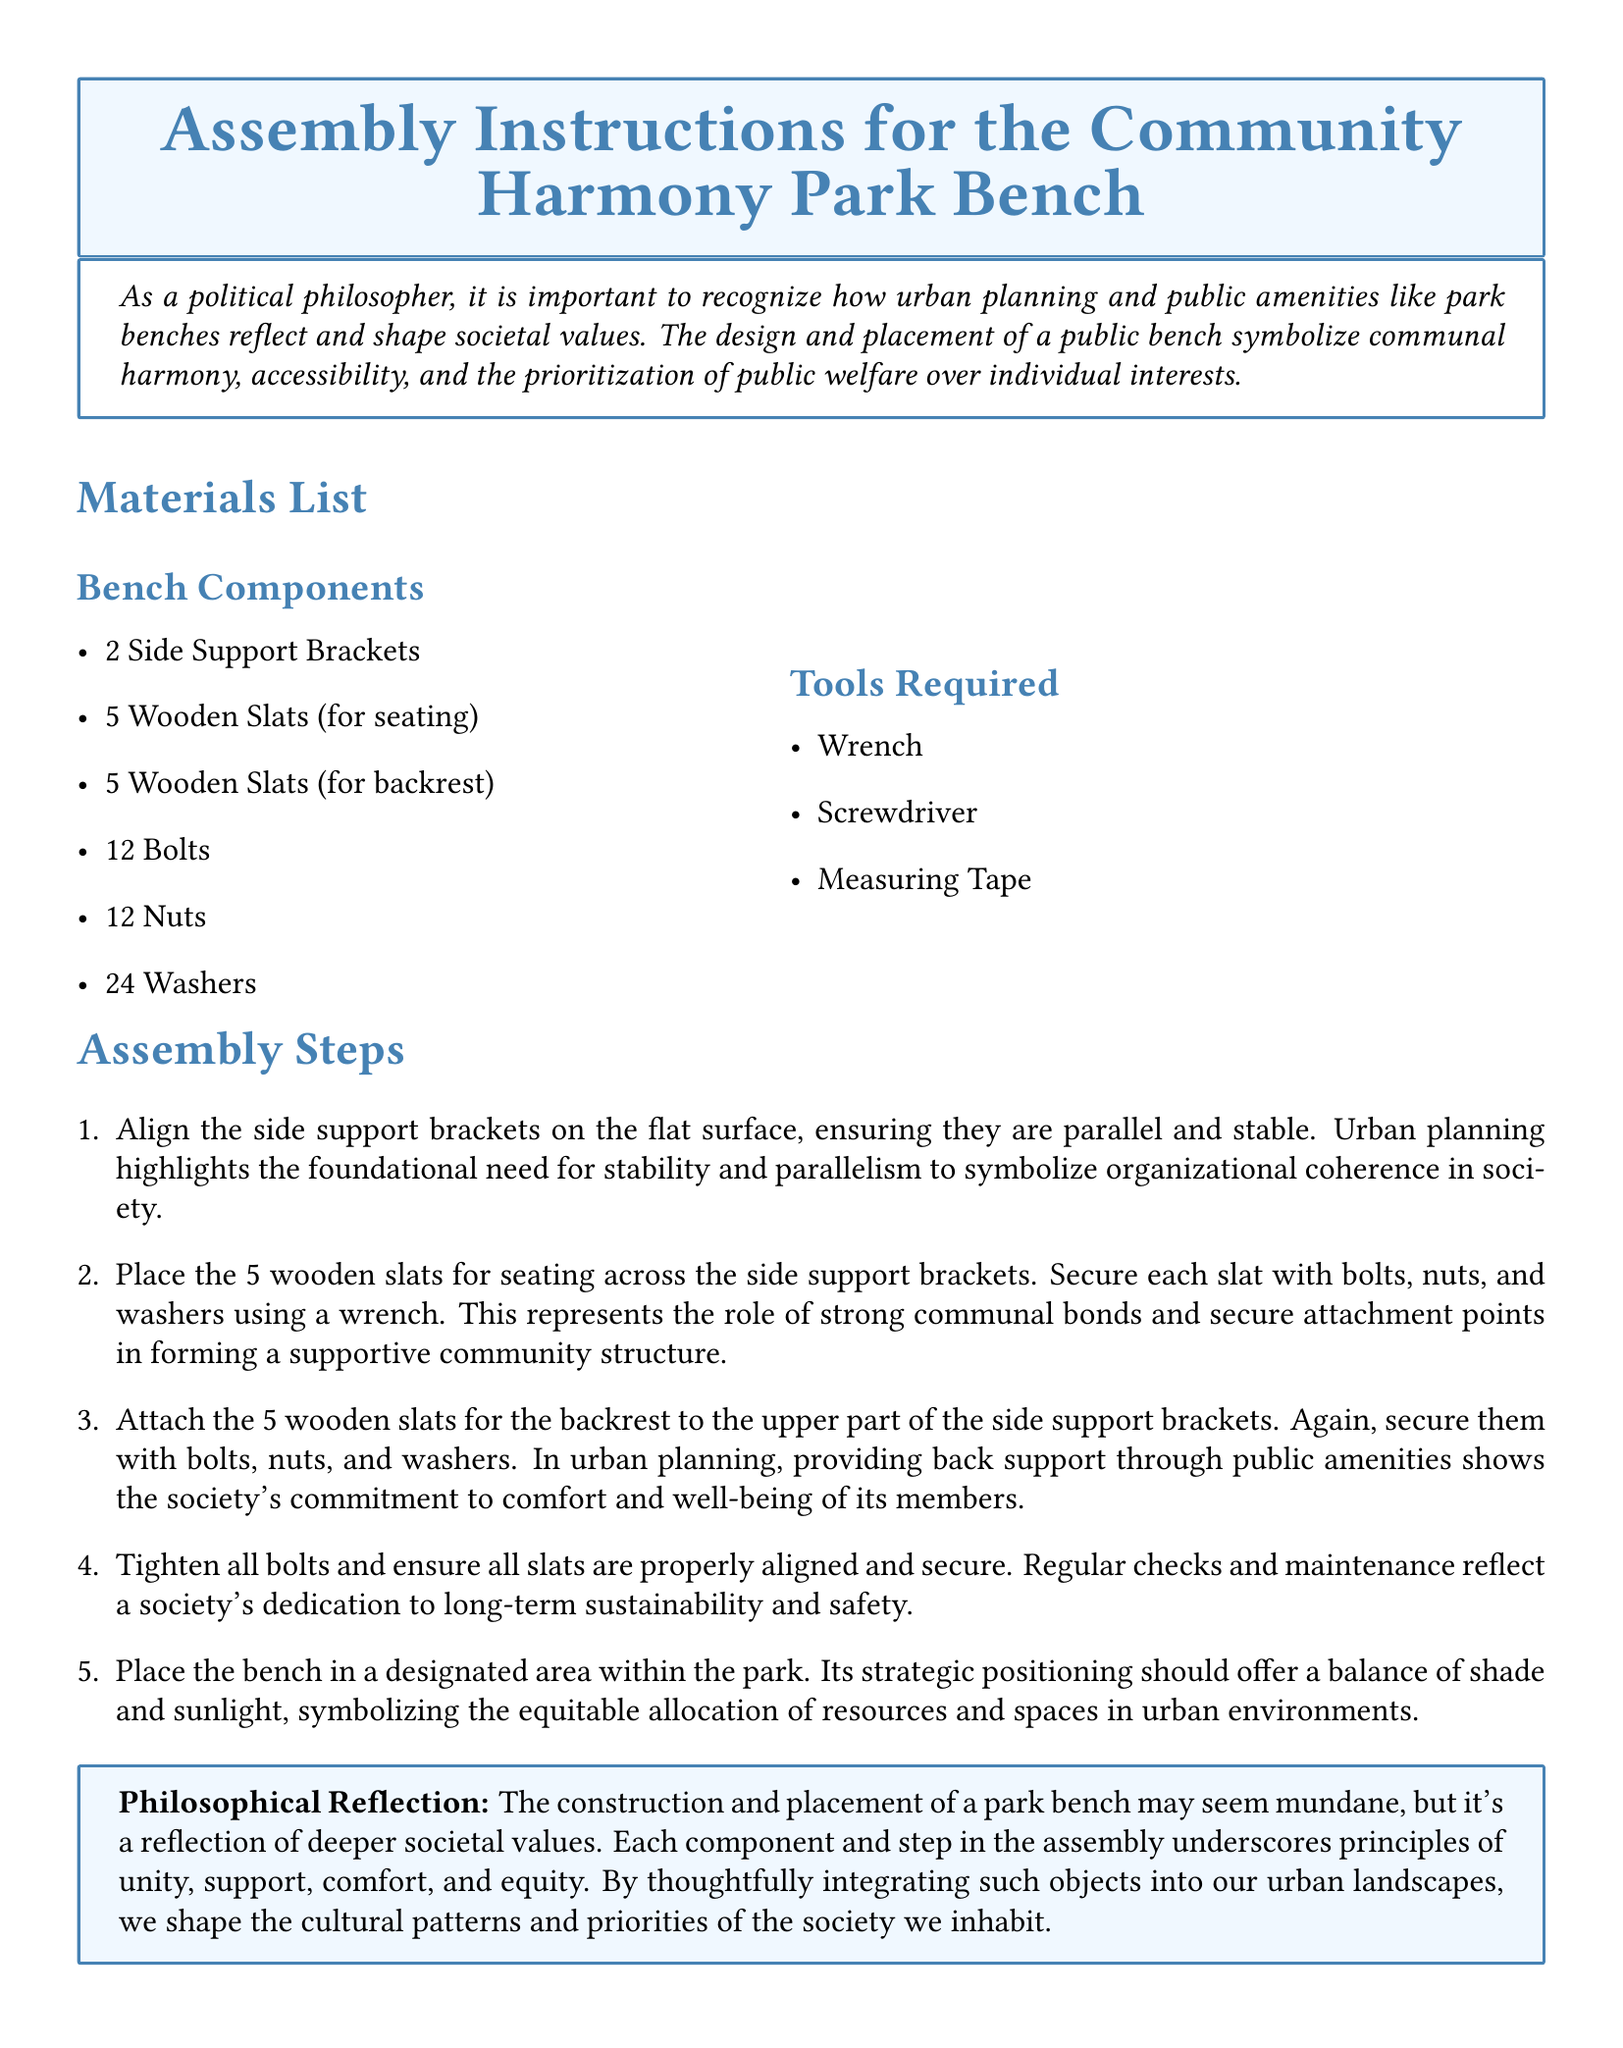What is the title of the document? The title is prominently displayed at the beginning of the document, stating the purpose of the instructions.
Answer: Assembly Instructions for the Community Harmony Park Bench How many wooden slats are used for seating? This information is found in the materials list where components are specified.
Answer: 5 What tool is required for assembly? The tools required are listed in a dedicated section of the document.
Answer: Wrench What do the side support brackets represent? The assembly steps provide symbolic meanings behind components in terms of societal values.
Answer: Organizational coherence How many nuts are needed for assembly? The number of each hardware component is mentioned in the materials list.
Answer: 12 What does providing back support symbolize in urban planning? The assembly steps link specific features of the bench to broader societal commitments.
Answer: Comfort and well-being What color is used for the box surrounding the title? The document specifies the color used for different sections, including the title box.
Answer: Second color What is emphasized through regular checks and maintenance? The context of well-being in society is discussed in relation to the importance of maintenance.
Answer: Long-term sustainability and safety How many assembly steps are there? The assembly process is broken into distinct steps, counted from the enumerated list.
Answer: 5 